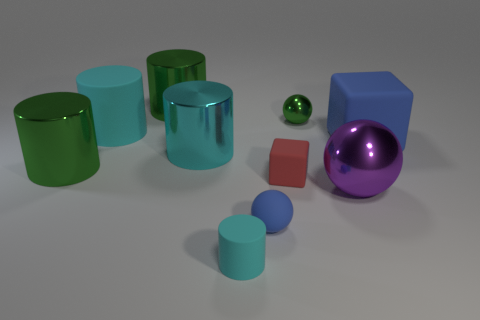How many other objects are there of the same size as the cyan metallic cylinder?
Keep it short and to the point. 5. What is the color of the big metal thing that is right of the cube on the left side of the large metal thing that is right of the tiny blue ball?
Keep it short and to the point. Purple. What number of other things are the same shape as the big blue object?
Your answer should be very brief. 1. What is the shape of the blue rubber thing behind the purple shiny object?
Your answer should be very brief. Cube. Are there any small red rubber things that are right of the blue matte block behind the cyan shiny object?
Give a very brief answer. No. There is a ball that is right of the red object and in front of the large blue matte thing; what is its color?
Ensure brevity in your answer.  Purple. Are there any tiny cyan cylinders that are to the left of the big green cylinder to the right of the large rubber object to the left of the tiny blue matte sphere?
Ensure brevity in your answer.  No. There is a purple metallic object that is the same shape as the tiny green object; what is its size?
Ensure brevity in your answer.  Large. Are there any other things that are the same material as the purple sphere?
Keep it short and to the point. Yes. Are there any blue metal balls?
Your answer should be very brief. No. 